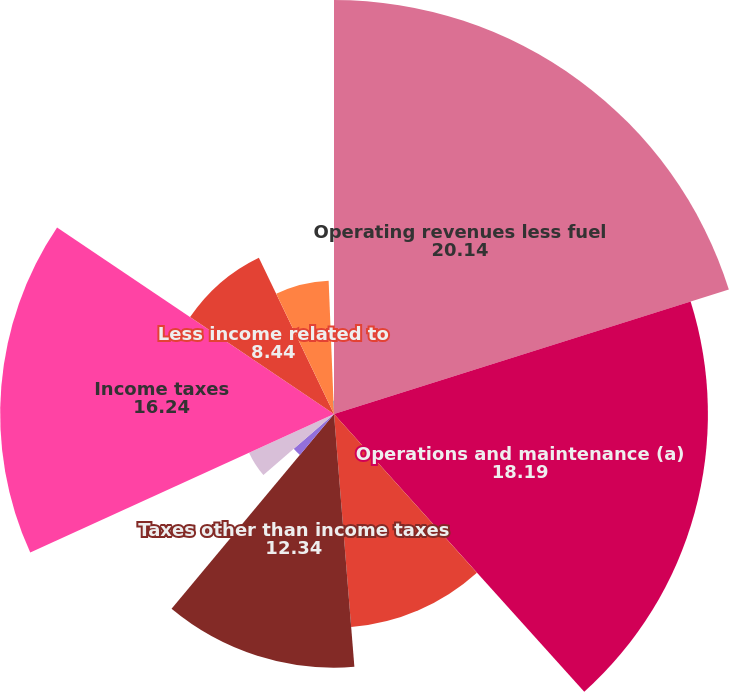Convert chart to OTSL. <chart><loc_0><loc_0><loc_500><loc_500><pie_chart><fcel>Operating revenues less fuel<fcel>Operations and maintenance (a)<fcel>Depreciation and amortization<fcel>Taxes other than income taxes<fcel>Other expenses net<fcel>Interest charges net of<fcel>Income taxes<fcel>Less income related to<fcel>Regulated electricity segment<fcel>Income from Continuing<nl><fcel>20.14%<fcel>18.19%<fcel>10.39%<fcel>12.34%<fcel>2.59%<fcel>4.54%<fcel>16.24%<fcel>8.44%<fcel>6.49%<fcel>0.64%<nl></chart> 